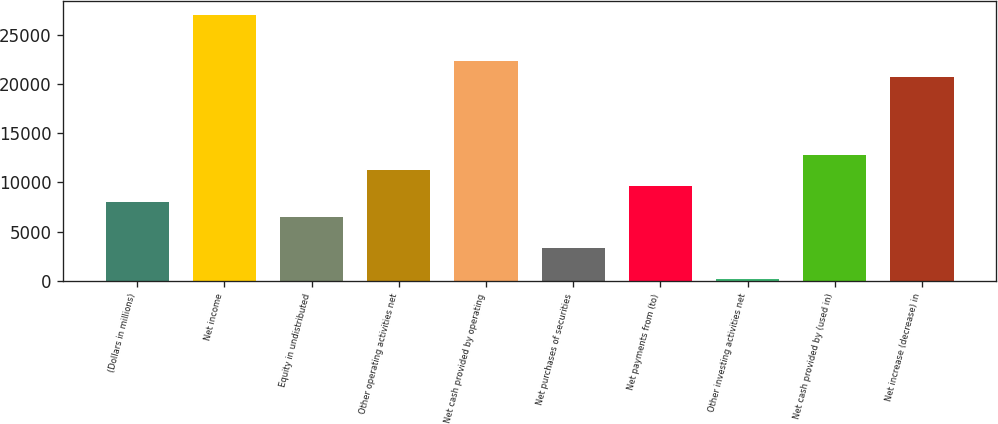<chart> <loc_0><loc_0><loc_500><loc_500><bar_chart><fcel>(Dollars in millions)<fcel>Net income<fcel>Equity in undistributed<fcel>Other operating activities net<fcel>Net cash provided by operating<fcel>Net purchases of securities<fcel>Net payments from (to)<fcel>Other investing activities net<fcel>Net cash provided by (used in)<fcel>Net increase (decrease) in<nl><fcel>8065.5<fcel>27043.5<fcel>6484<fcel>11228.5<fcel>22299<fcel>3321<fcel>9647<fcel>158<fcel>12810<fcel>20717.5<nl></chart> 